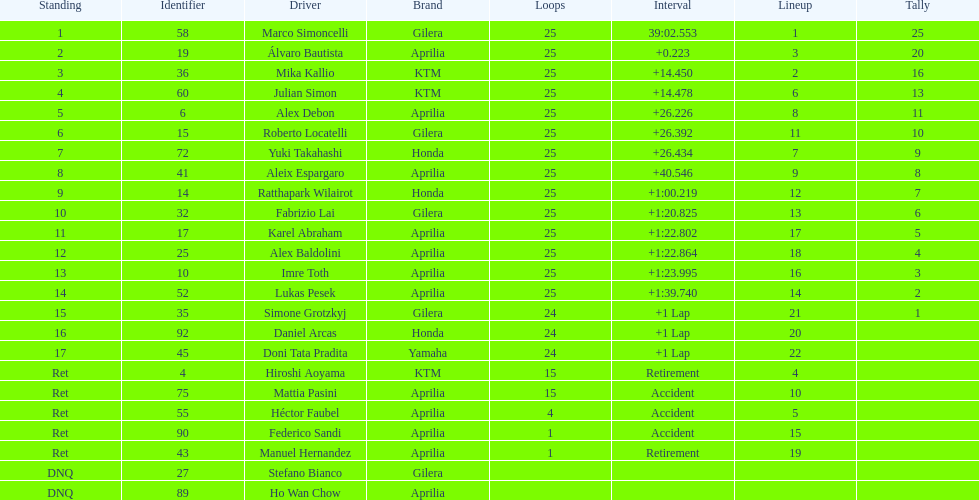Who is marco simoncelli's manufacturer Gilera. 